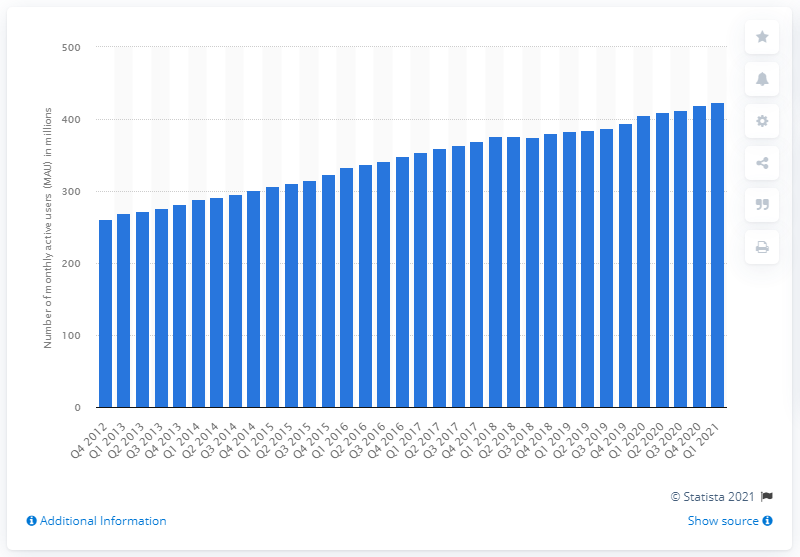Point out several critical features in this image. In the first quarter of 2021, Facebook had 423 million monthly active users. Facebook had 423 million monthly active users in the first quarter of 2021. 